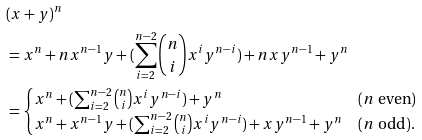Convert formula to latex. <formula><loc_0><loc_0><loc_500><loc_500>& ( x + y ) ^ { n } \\ & = x ^ { n } + n x ^ { n - 1 } y + ( \sum _ { i = 2 } ^ { n - 2 } \binom { n } { i } x ^ { i } y ^ { n - i } ) + n x y ^ { n - 1 } + y ^ { n } \\ & = \begin{cases} x ^ { n } + ( \sum _ { i = 2 } ^ { n - 2 } \binom { n } { i } x ^ { i } y ^ { n - i } ) + y ^ { n } & ( n \text { even} ) \\ x ^ { n } + x ^ { n - 1 } y + ( \sum _ { i = 2 } ^ { n - 2 } \binom { n } { i } x ^ { i } y ^ { n - i } ) + x y ^ { n - 1 } + y ^ { n } & ( n \text { odd} ) . \end{cases}</formula> 